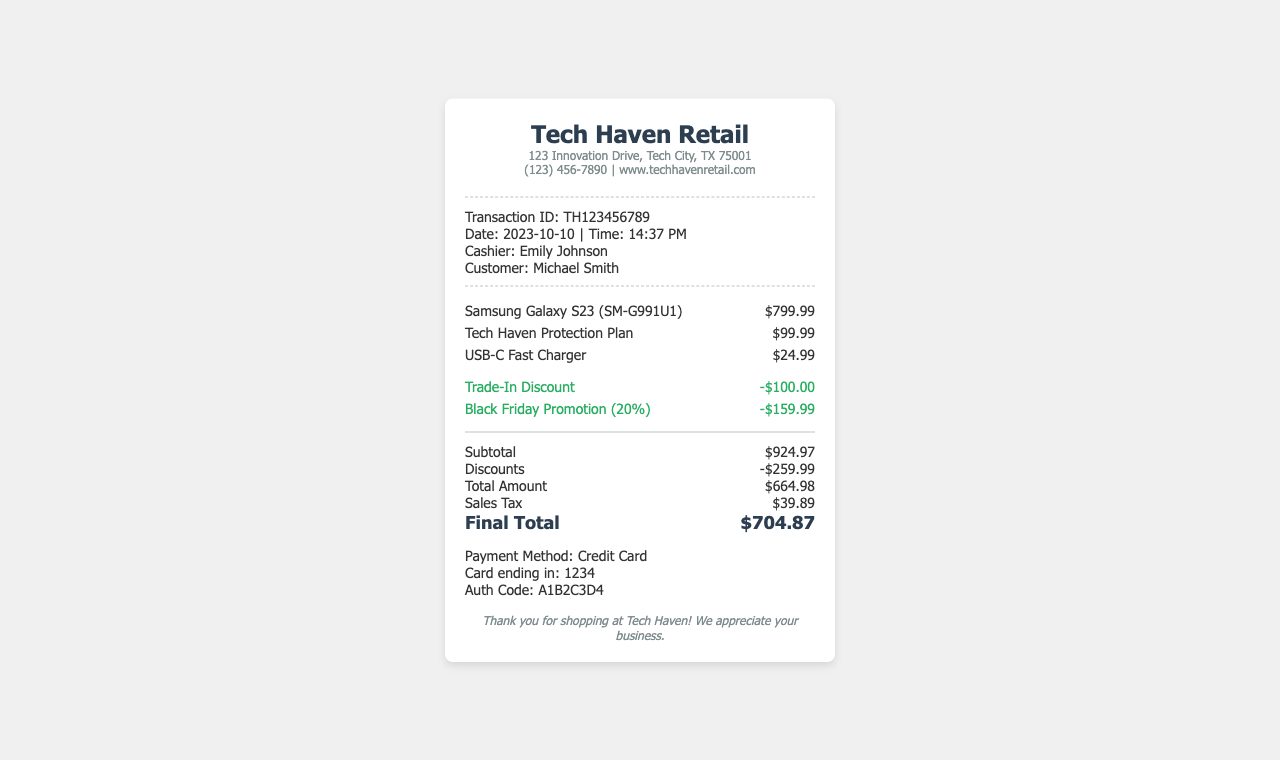What is the transaction ID? The transaction ID is included in the transaction information section of the document.
Answer: TH123456789 Who is the cashier? The cashier's name is mentioned in the transaction information.
Answer: Emily Johnson What is the total amount before discounts? The total amount before discounts is the subtotal provided in the totals section.
Answer: $924.97 How much is the Trade-In Discount? The amount for the Trade-In Discount is displayed in the discounts section.
Answer: -$100.00 What is the final total after tax? The final total is the last amount listed in the totals section after all discounts and taxes.
Answer: $704.87 What product has a protection plan? The item description that includes the protection plan is listed in the items section.
Answer: Tech Haven Protection Plan What payment method was used? The payment method is specified in the payment information section.
Answer: Credit Card What is the date of the transaction? The date of the transaction is shown in the transaction information section.
Answer: 2023-10-10 How much is the sales tax? The sales tax amount is indicated in the totals section.
Answer: $39.89 